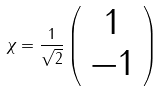Convert formula to latex. <formula><loc_0><loc_0><loc_500><loc_500>\chi = \frac { 1 } { \sqrt { 2 } } \left ( \begin{array} { c } 1 \\ - 1 \end{array} \right )</formula> 